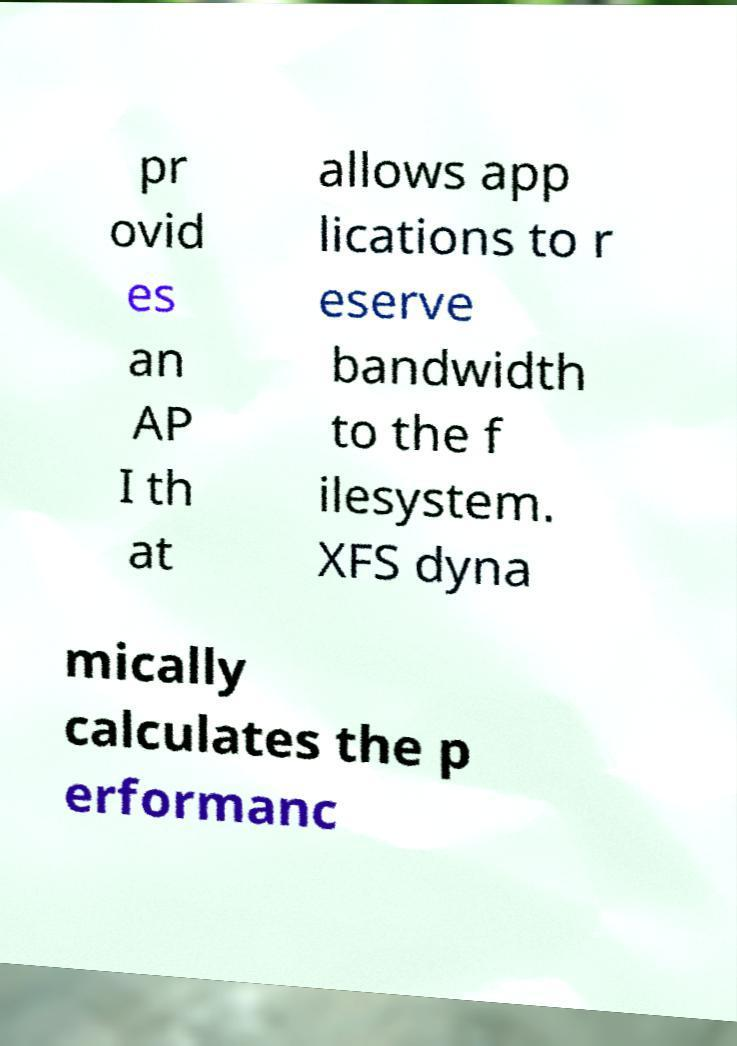I need the written content from this picture converted into text. Can you do that? pr ovid es an AP I th at allows app lications to r eserve bandwidth to the f ilesystem. XFS dyna mically calculates the p erformanc 